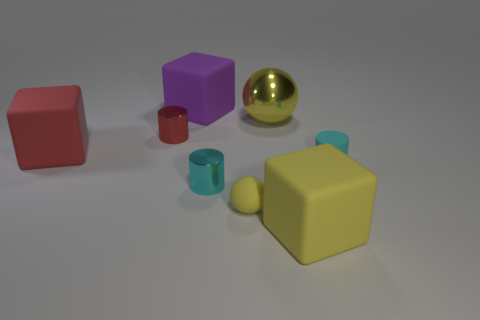Does the yellow cube have the same material as the small red cylinder?
Keep it short and to the point. No. What number of other objects are the same shape as the tiny yellow object?
Keep it short and to the point. 1. Are there any large red cylinders made of the same material as the small yellow sphere?
Your answer should be compact. No. What material is the yellow ball that is the same size as the yellow matte cube?
Your response must be concise. Metal. There is a big cube in front of the tiny rubber thing that is left of the big rubber block that is on the right side of the big purple thing; what is its color?
Offer a very short reply. Yellow. There is a large object that is left of the big purple matte block; is it the same shape as the metal thing behind the red metallic thing?
Keep it short and to the point. No. How many big yellow metallic objects are there?
Provide a short and direct response. 1. The metal sphere that is the same size as the red matte object is what color?
Provide a succinct answer. Yellow. Are the yellow sphere that is behind the red matte thing and the large cube on the left side of the purple cube made of the same material?
Make the answer very short. No. What is the size of the cyan thing on the right side of the yellow matte cube in front of the red shiny cylinder?
Ensure brevity in your answer.  Small. 